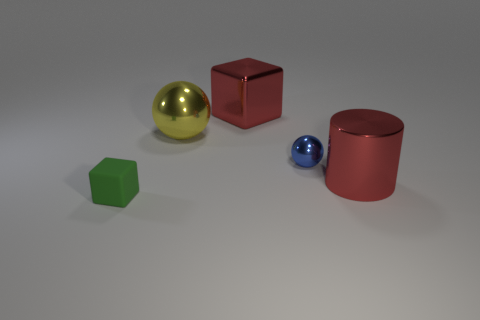Add 1 small green blocks. How many objects exist? 6 Subtract all cubes. How many objects are left? 3 Add 2 big red things. How many big red things are left? 4 Add 5 purple metallic cubes. How many purple metallic cubes exist? 5 Subtract 0 green cylinders. How many objects are left? 5 Subtract all small yellow matte cylinders. Subtract all big metal objects. How many objects are left? 2 